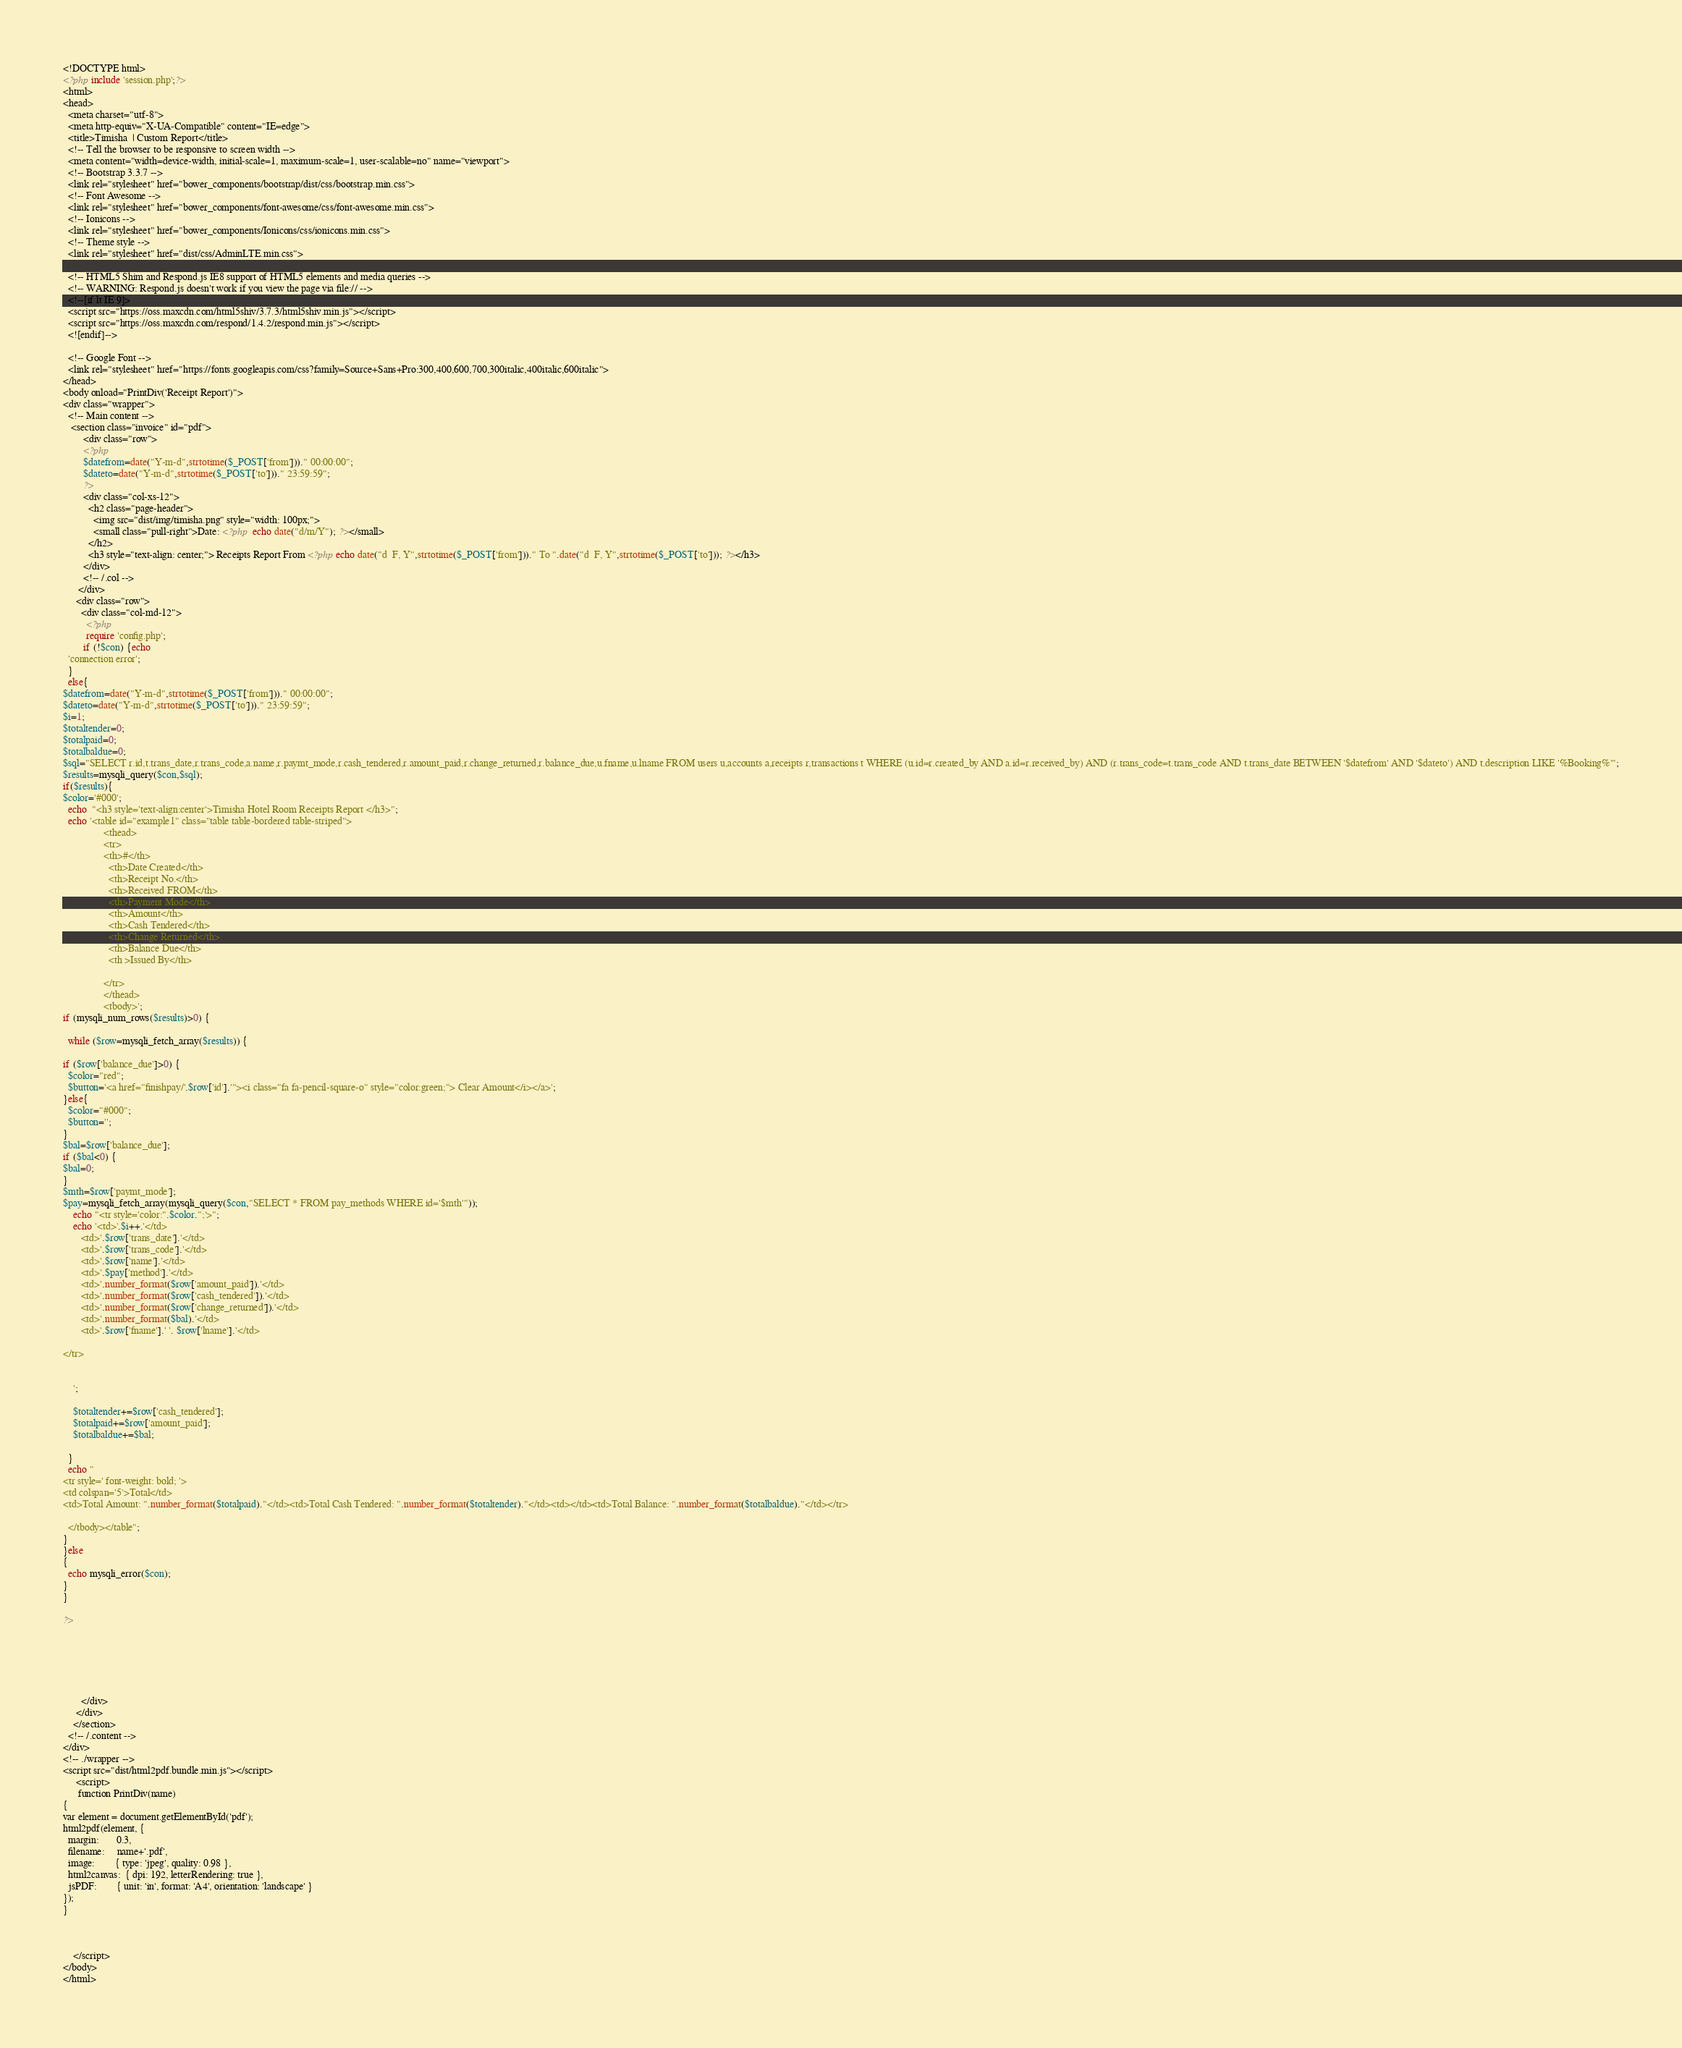Convert code to text. <code><loc_0><loc_0><loc_500><loc_500><_PHP_><!DOCTYPE html>
<?php include 'session.php';?>
<html>
<head>
  <meta charset="utf-8">
  <meta http-equiv="X-UA-Compatible" content="IE=edge">
  <title>Timisha  | Custom Report</title>
  <!-- Tell the browser to be responsive to screen width -->
  <meta content="width=device-width, initial-scale=1, maximum-scale=1, user-scalable=no" name="viewport">
  <!-- Bootstrap 3.3.7 -->
  <link rel="stylesheet" href="bower_components/bootstrap/dist/css/bootstrap.min.css">
  <!-- Font Awesome -->
  <link rel="stylesheet" href="bower_components/font-awesome/css/font-awesome.min.css">
  <!-- Ionicons -->
  <link rel="stylesheet" href="bower_components/Ionicons/css/ionicons.min.css">
  <!-- Theme style -->
  <link rel="stylesheet" href="dist/css/AdminLTE.min.css">

  <!-- HTML5 Shim and Respond.js IE8 support of HTML5 elements and media queries -->
  <!-- WARNING: Respond.js doesn't work if you view the page via file:// -->
  <!--[if lt IE 9]>
  <script src="https://oss.maxcdn.com/html5shiv/3.7.3/html5shiv.min.js"></script>
  <script src="https://oss.maxcdn.com/respond/1.4.2/respond.min.js"></script>
  <![endif]-->

  <!-- Google Font -->
  <link rel="stylesheet" href="https://fonts.googleapis.com/css?family=Source+Sans+Pro:300,400,600,700,300italic,400italic,600italic">
</head>
<body onload="PrintDiv('Receipt Report')">
<div class="wrapper">
  <!-- Main content -->
   <section class="invoice" id="pdf">
        <div class="row">
        <?php 
        $datefrom=date("Y-m-d",strtotime($_POST['from']))." 00:00:00";
        $dateto=date("Y-m-d",strtotime($_POST['to']))." 23:59:59";  
        ?>
        <div class="col-xs-12">
          <h2 class="page-header">
            <img src="dist/img/timisha.png" style="width: 100px;">
            <small class="pull-right">Date: <?php  echo date("d/m/Y"); ?></small>
          </h2>
          <h3 style="text-align: center;"> Receipts Report From <?php echo date("d  F, Y",strtotime($_POST['from']))." To ".date("d  F, Y",strtotime($_POST['to'])); ?></h3>
        </div>
        <!-- /.col -->
      </div>
     <div class="row">
       <div class="col-md-12">
         <?php 
         require 'config.php';
        if (!$con) {echo 
  'connection error';
  }
  else{
$datefrom=date("Y-m-d",strtotime($_POST['from']))." 00:00:00";
$dateto=date("Y-m-d",strtotime($_POST['to']))." 23:59:59";     
$i=1;
$totaltender=0;
$totalpaid=0;
$totalbaldue=0;
$sql="SELECT r.id,t.trans_date,r.trans_code,a.name,r.paymt_mode,r.cash_tendered,r.amount_paid,r.change_returned,r.balance_due,u.fname,u.lname FROM users u,accounts a,receipts r,transactions t WHERE (u.id=r.created_by AND a.id=r.received_by) AND (r.trans_code=t.trans_code AND t.trans_date BETWEEN '$datefrom' AND '$dateto') AND t.description LIKE '%Booking%'";
$results=mysqli_query($con,$sql);
if($results){
$color='#000';
  echo  "<h3 style='text-align:center'>Timisha Hotel Room Receipts Report </h3>";
  echo '<table id="example1" class="table table-bordered table-striped">
                <thead>
                <tr>
                <th>#</th>
                  <th>Date Created</th>
                  <th>Receipt No.</th>
                  <th>Received FROM</th>
                  <th>Payment Mode</th>
                  <th>Amount</th>
                  <th>Cash Tendered</th>
                  <th>Change Returned</th>
                  <th>Balance Due</th>
                  <th >Issued By</th>
             
                </tr>
                </thead>
                <tbody>';
if (mysqli_num_rows($results)>0) {

  while ($row=mysqli_fetch_array($results)) {

if ($row['balance_due']>0) {
  $color="red";
  $button='<a href="finishpay/'.$row['id'].'"><i class="fa fa-pencil-square-o" style="color:green;"> Clear Amount</i></a>';
}else{
  $color="#000";
  $button='';
}
$bal=$row['balance_due'];
if ($bal<0) {
$bal=0;
}
$mth=$row['paymt_mode'];
$pay=mysqli_fetch_array(mysqli_query($con,"SELECT * FROM pay_methods WHERE id='$mth'"));
    echo "<tr style='color:".$color.";'>";
    echo '<td>'.$i++.'</td>
       <td>'.$row['trans_date'].'</td>
       <td>'.$row['trans_code'].'</td>
       <td>'.$row['name'].'</td>
       <td>'.$pay['method'].'</td>
       <td>'.number_format($row['amount_paid']).'</td>
       <td>'.number_format($row['cash_tendered']).'</td>
       <td>'.number_format($row['change_returned']).'</td>
       <td>'.number_format($bal).'</td>
       <td>'.$row['fname'].' '. $row['lname'].'</td>
      
</tr>


    ';

    $totaltender+=$row['cash_tendered'];
    $totalpaid+=$row['amount_paid'];
    $totalbaldue+=$bal;

  }
  echo "
<tr style=' font-weight: bold; '>
<td colspan='5'>Total</td>
<td>Total Amount: ".number_format($totalpaid)."</td><td>Total Cash Tendered: ".number_format($totaltender)."</td><td></td><td>Total Balance: ".number_format($totalbaldue)."</td></tr>

  </tbody></table";
}
}else
{
  echo mysqli_error($con);
}
}

?>


        



       </div>
     </div>
    </section>
  <!-- /.content -->
</div>
<!-- ./wrapper -->
<script src="dist/html2pdf.bundle.min.js"></script>
     <script> 
      function PrintDiv(name)
{
var element = document.getElementById('pdf');
html2pdf(element, {
  margin:       0.3,
  filename:     name+'.pdf',
  image:        { type: 'jpeg', quality: 0.98 },
  html2canvas:  { dpi: 192, letterRendering: true },
  jsPDF:        { unit: 'in', format: 'A4', orientation: 'landscape' }
});
}



    </script>
</body>
</html>
</code> 